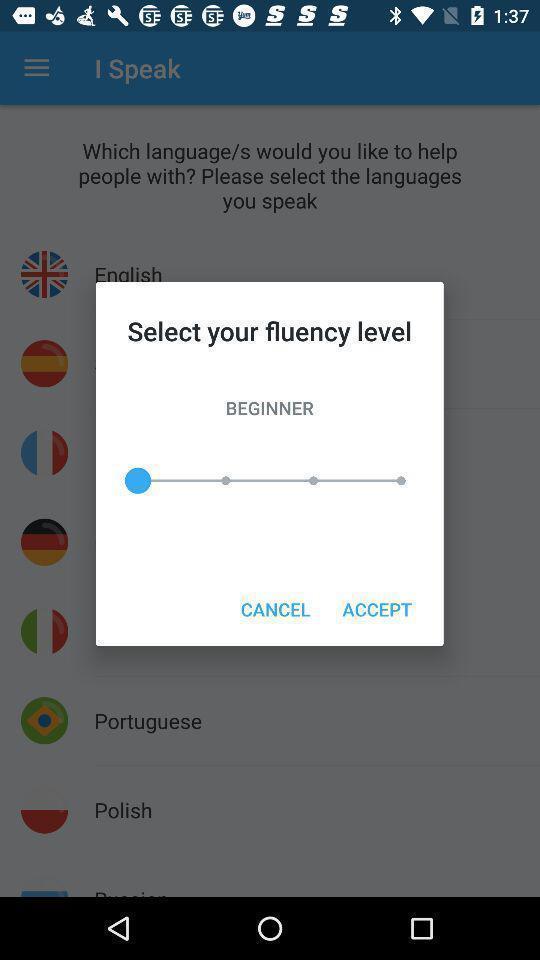Describe the key features of this screenshot. Popup to accept in the language learning app. 